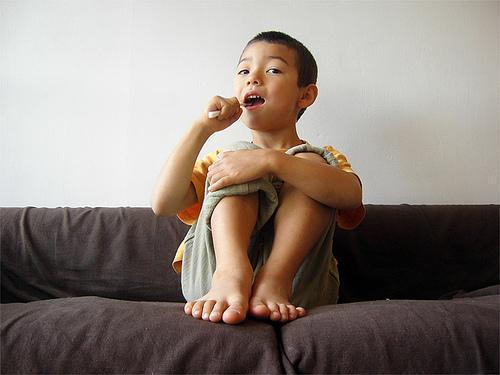How many zebras are in the photo?
Give a very brief answer. 0. 